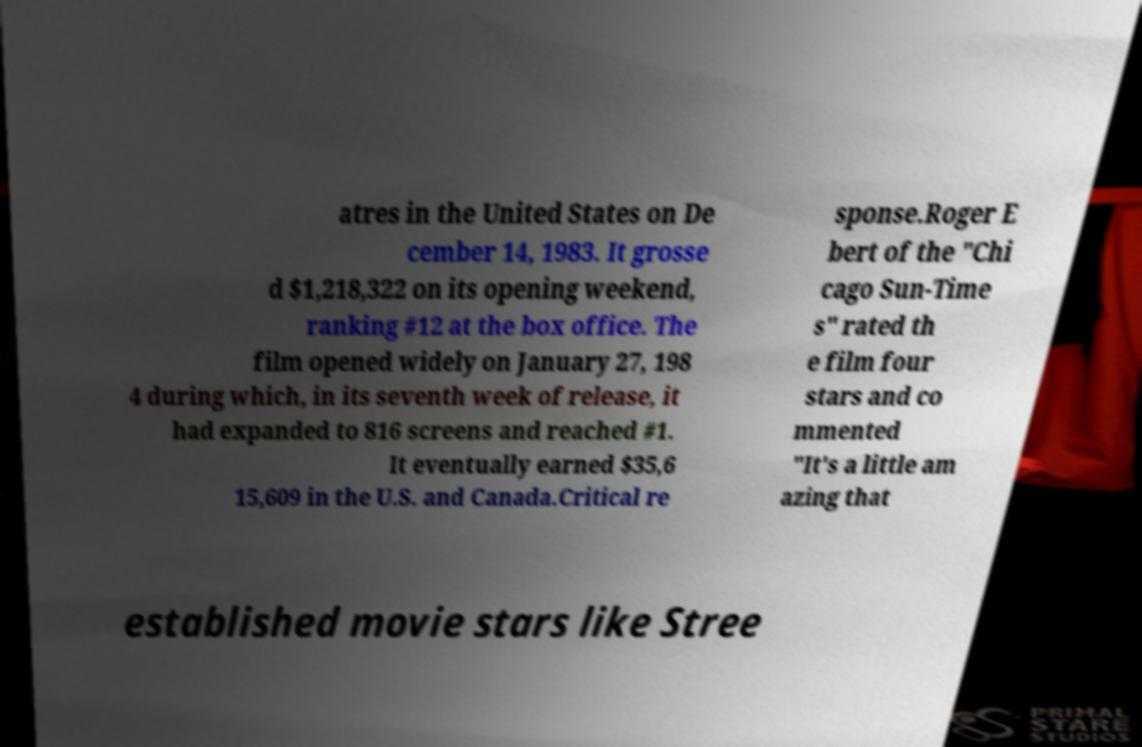For documentation purposes, I need the text within this image transcribed. Could you provide that? atres in the United States on De cember 14, 1983. It grosse d $1,218,322 on its opening weekend, ranking #12 at the box office. The film opened widely on January 27, 198 4 during which, in its seventh week of release, it had expanded to 816 screens and reached #1. It eventually earned $35,6 15,609 in the U.S. and Canada.Critical re sponse.Roger E bert of the "Chi cago Sun-Time s" rated th e film four stars and co mmented "It's a little am azing that established movie stars like Stree 